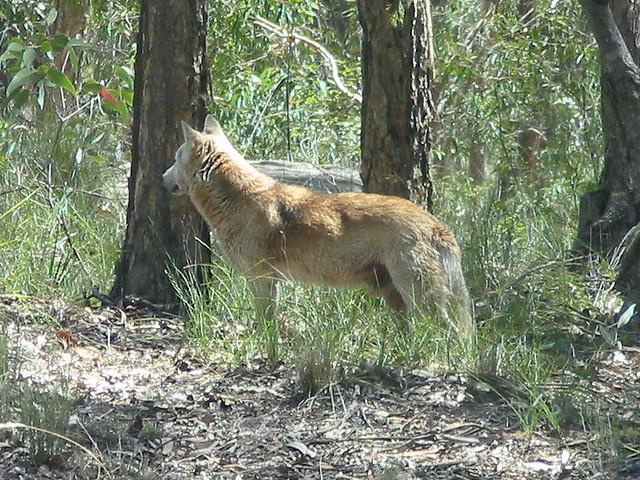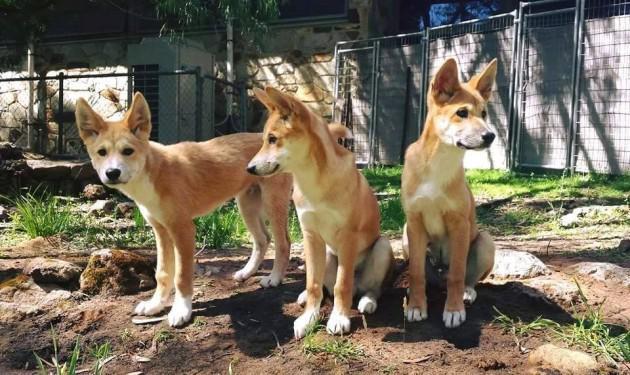The first image is the image on the left, the second image is the image on the right. Given the left and right images, does the statement "A single dog is standing on the ground in the woods in the image on the left." hold true? Answer yes or no. Yes. The first image is the image on the left, the second image is the image on the right. Examine the images to the left and right. Is the description "There are exactly three dogs in total." accurate? Answer yes or no. No. 